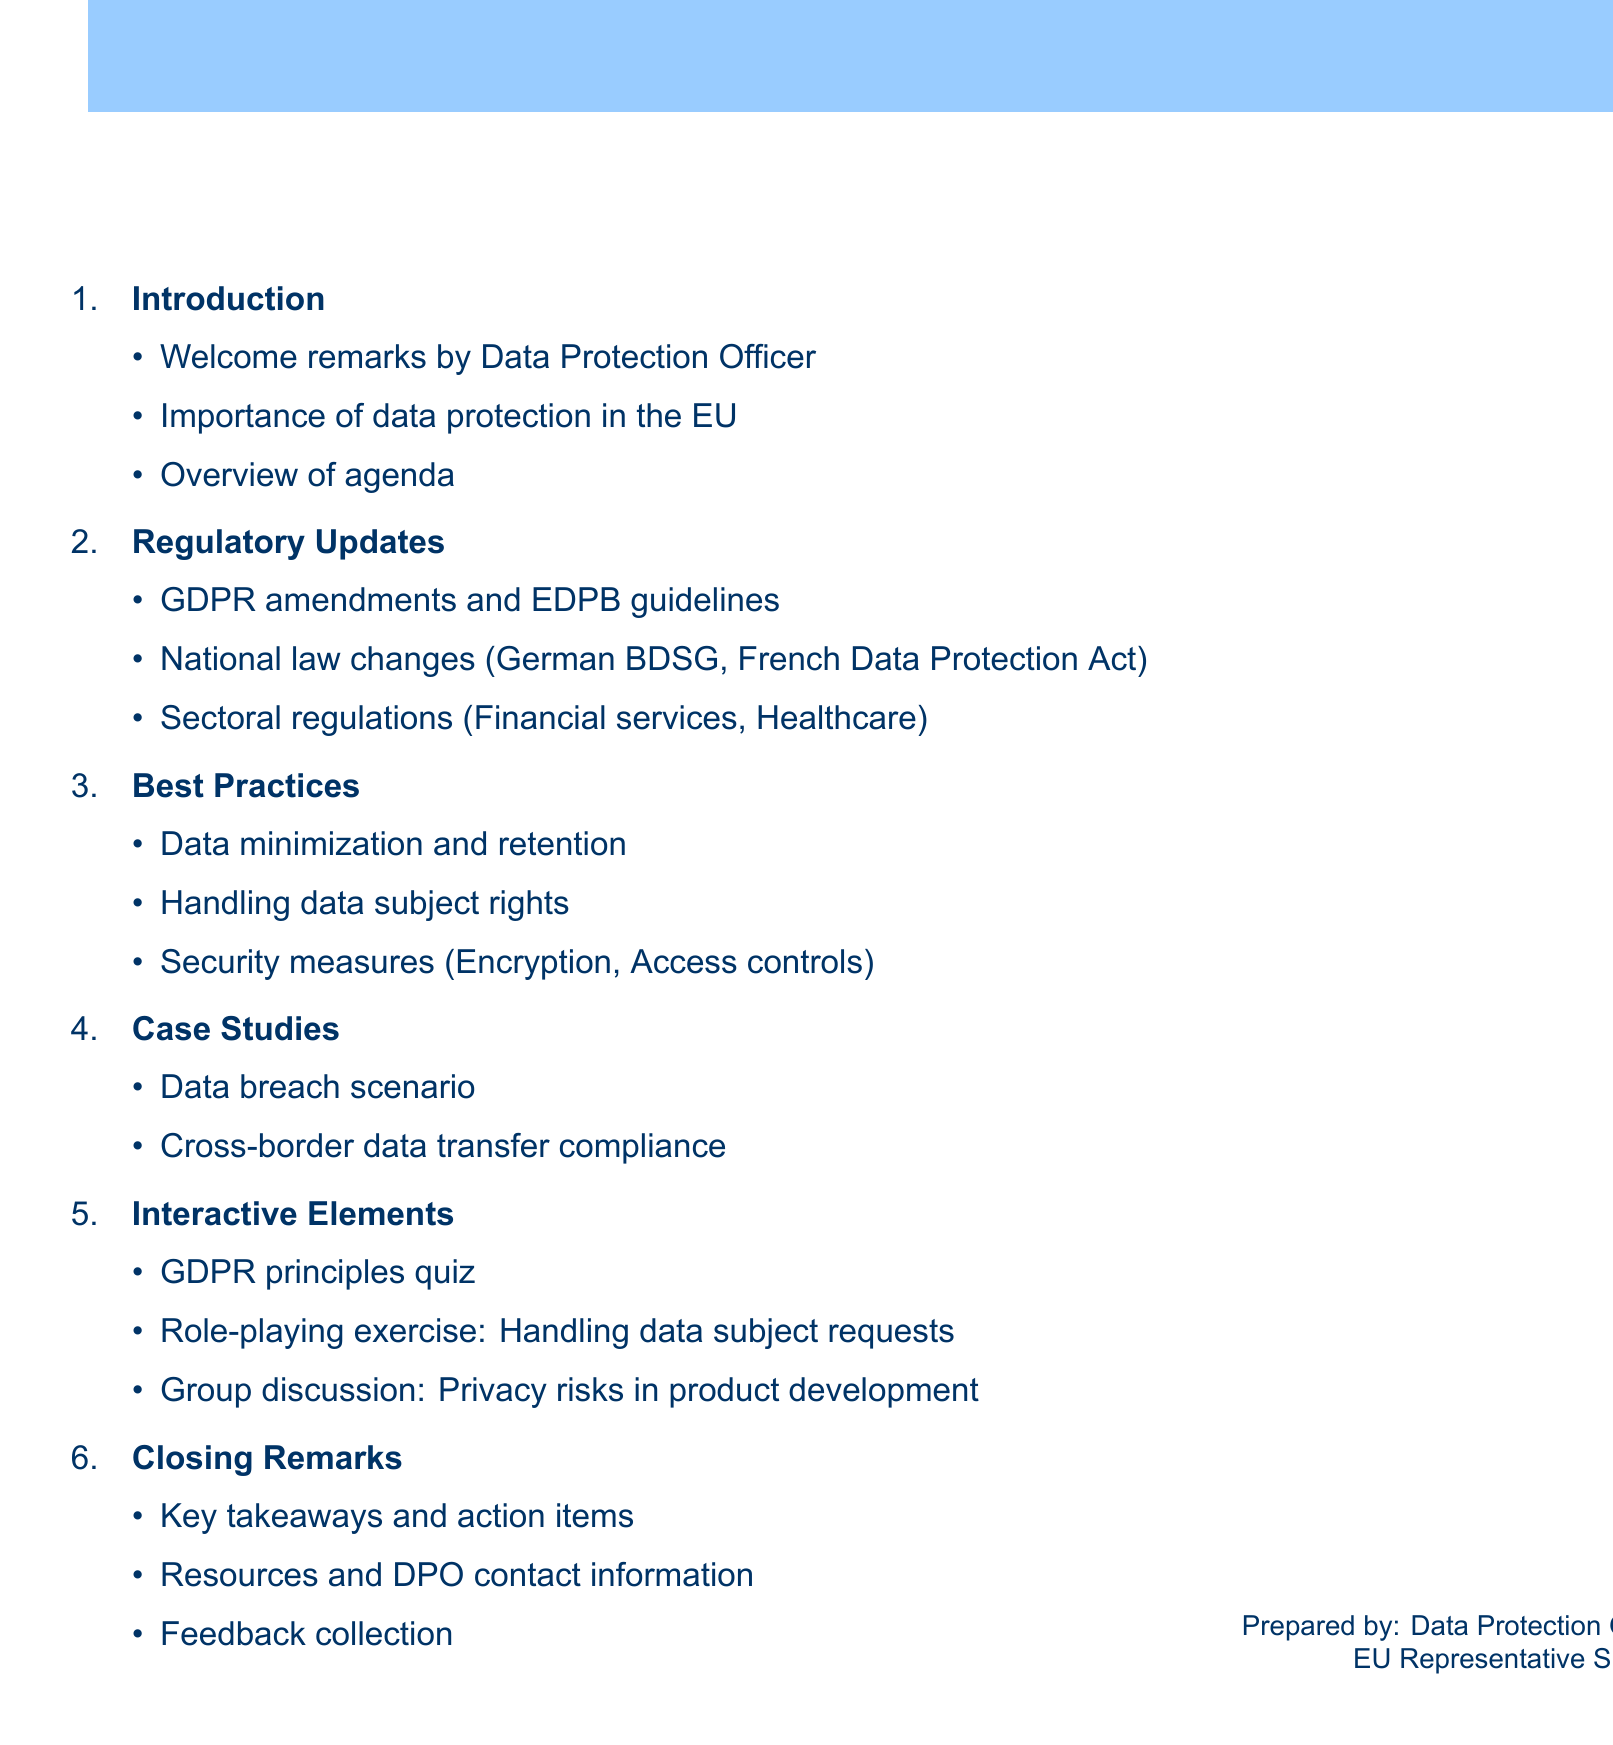What is the title of the training session? The title provides the main theme of the session detailed in the document.
Answer: Bi-annual Data Protection Training: Regulatory Updates and Best Practices Who gives the welcome remarks? The document states who is responsible for the welcome remarks during the introduction.
Answer: Data Protection Officer What recent ruling is mentioned in the regulatory updates? This question focuses on the significant court decision highlighted in the document.
Answer: Schrems II What is one of the topics covered under best practices? There are several topics outlined; this question seeks to identify one specific area.
Answer: Data minimization What incident is described in the case studies? This question aims to extract specific information about the scenario provided in the case studies section.
Answer: Unauthorized access to customer database Which quiz is included as an interactive element? The question targets the specific assessment mentioned in the interactive components.
Answer: GDPR principles and data subject rights assessment What resource is provided during the closing remarks? The closing section lists various kinds of resources available to participants.
Answer: Internal privacy policies How many interactive elements are listed? This question seeks to quantify the interactive components presented in the document.
Answer: Three 